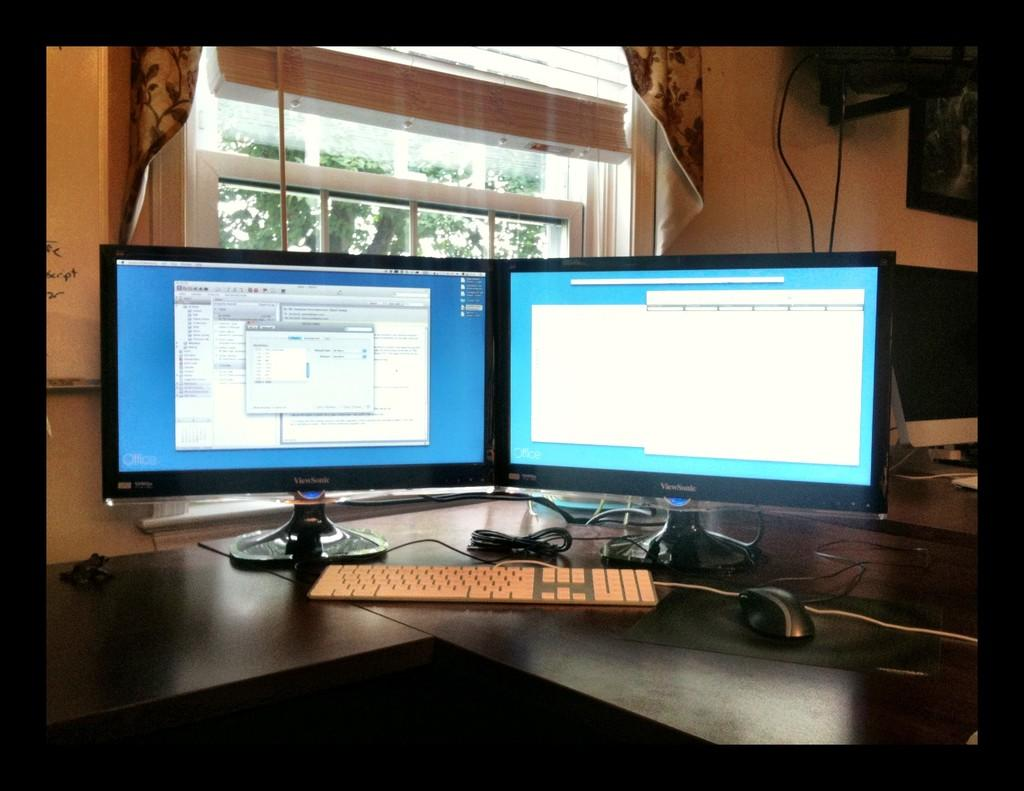<image>
Create a compact narrative representing the image presented. Two ViewSonic monitors showing documents from Microsoft Office. 